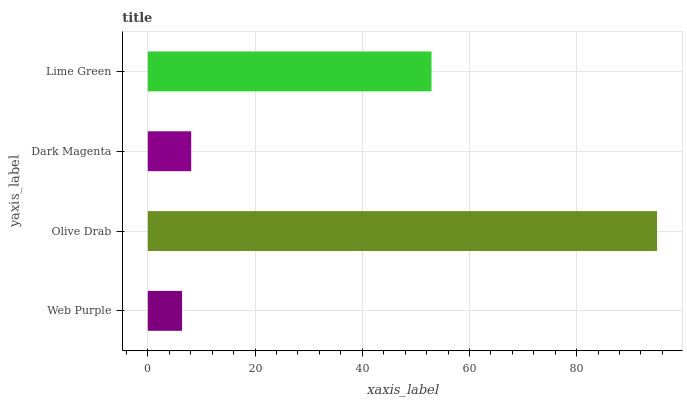Is Web Purple the minimum?
Answer yes or no. Yes. Is Olive Drab the maximum?
Answer yes or no. Yes. Is Dark Magenta the minimum?
Answer yes or no. No. Is Dark Magenta the maximum?
Answer yes or no. No. Is Olive Drab greater than Dark Magenta?
Answer yes or no. Yes. Is Dark Magenta less than Olive Drab?
Answer yes or no. Yes. Is Dark Magenta greater than Olive Drab?
Answer yes or no. No. Is Olive Drab less than Dark Magenta?
Answer yes or no. No. Is Lime Green the high median?
Answer yes or no. Yes. Is Dark Magenta the low median?
Answer yes or no. Yes. Is Dark Magenta the high median?
Answer yes or no. No. Is Web Purple the low median?
Answer yes or no. No. 